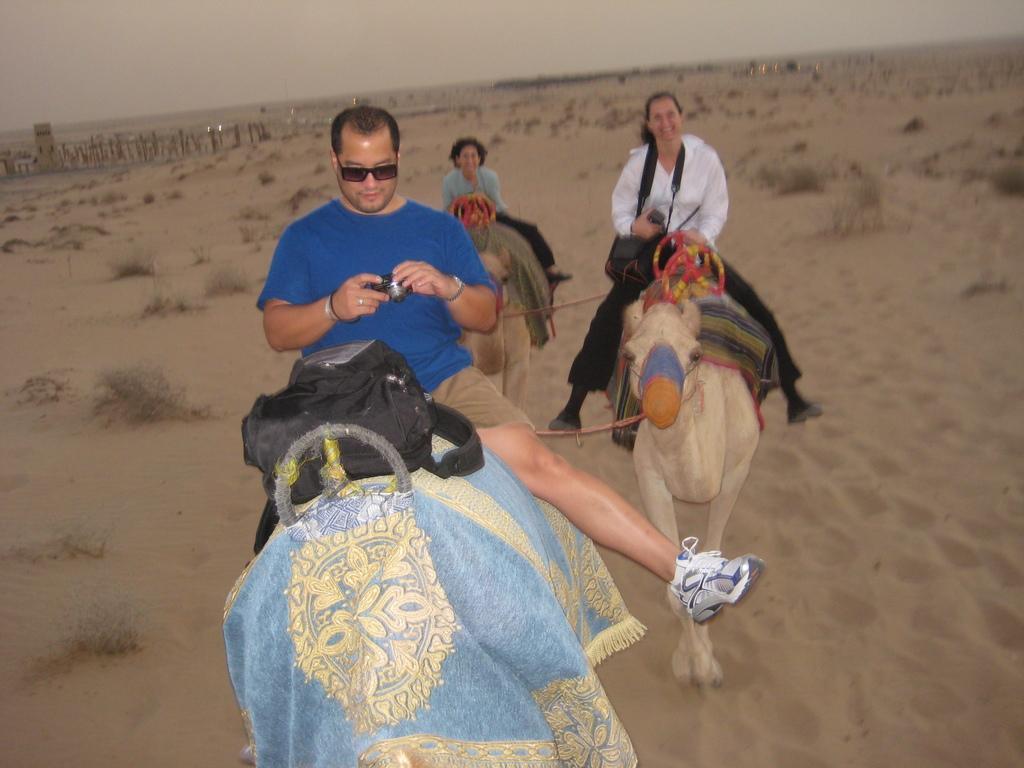In one or two sentences, can you explain what this image depicts? This image is taken outdoors. At the top of the image there is the sky. In the middle of the image a man and two women are sitting on the camels. A man is holding a camera in his hands. In the background there is a ground with sand and there are a few dried plants. 